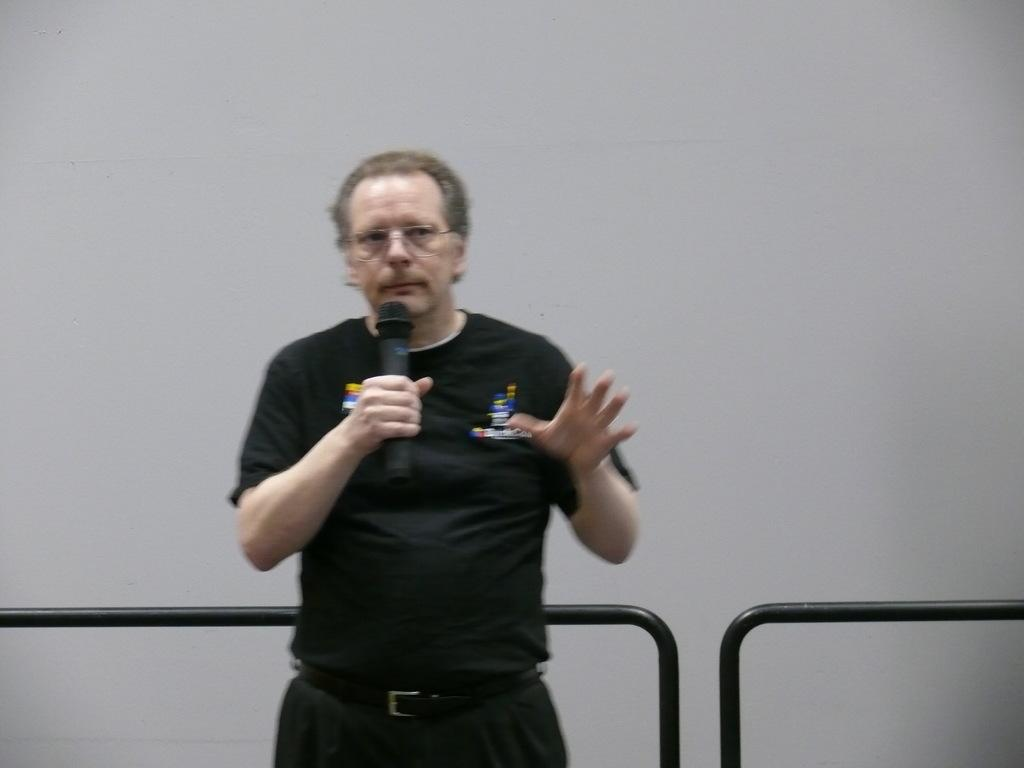What is the color of the wall in the image? The wall in the image is white. Who is present in the image? A man is present in the image. What is the man wearing? The man is wearing a black color t-shirt. What is the man holding in the image? The man is holding a mic. Is there a sponge visible in the image? No, there is no sponge present in the image. Is the man standing near an oven in the image? No, there is no oven present in the image. 